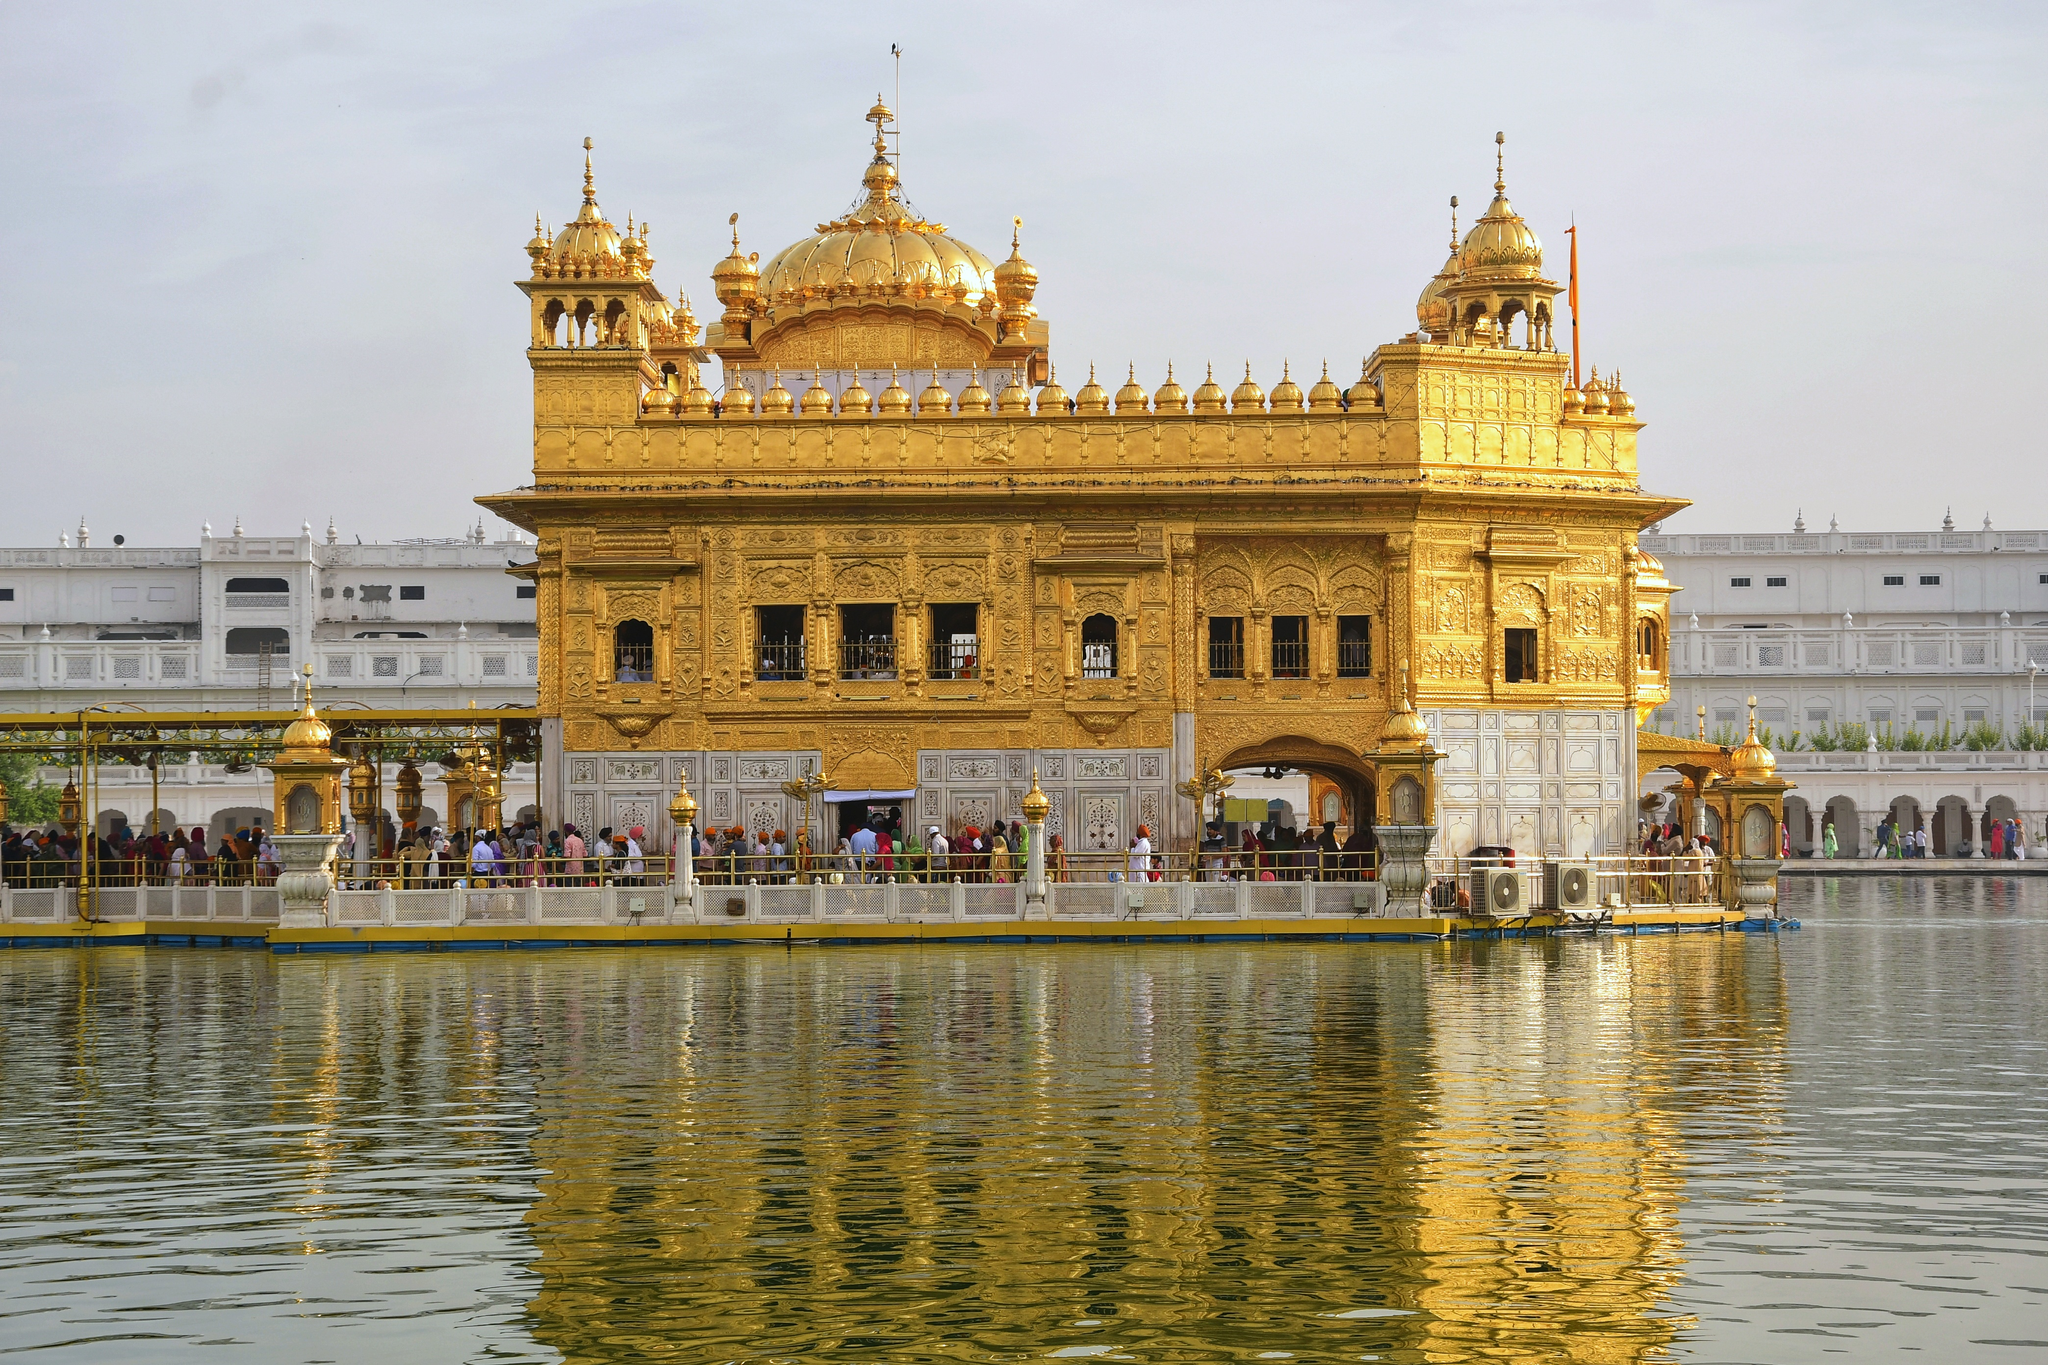Imagine you are a watercolor artist. Describe how you would paint the Golden Temple in the scene. As a watercolor artist, I would begin with a delicate wash of muted blues and grays to capture the overcast sky, gently transitioning into the golden hues of the temple. Using fine brushes, I would meticulously outline the intricate details of the temple’s architecture, ensuring each dome and spire gleams with the richness of gold. The reflection in the water would be softly blended, creating a mirror image with fluid strokes, where the colors dissolve into each other. The figures of people would be painted with light touches, hinting at movement and life, while the surrounding marble pathways would be depicted with clean, crisp lines. The overall composition would aim to evoke a sense of tranquility and reverence, capturing the sacred tranquility of the Golden Temple. What feelings would you try to evoke with your painting? With my painting, I would strive to evoke a sense of peace, spirituality, and awe. The gentle interplay of watercolors would aim to reflect the serene and soothing atmosphere of the Golden Temple. I would focus on the luminous quality of the golden temple against the calm backdrop to highlight its divine ambiance. The reflective water would symbolize tranquility and timelessness, encouraging viewers to lose themselves in the calm. The presence of devotees would add a human touch, emphasizing a shared sense of faith and community, while the overall composition would invite contemplation and appreciation for the spiritual and architectural beauty of this sacred site. 